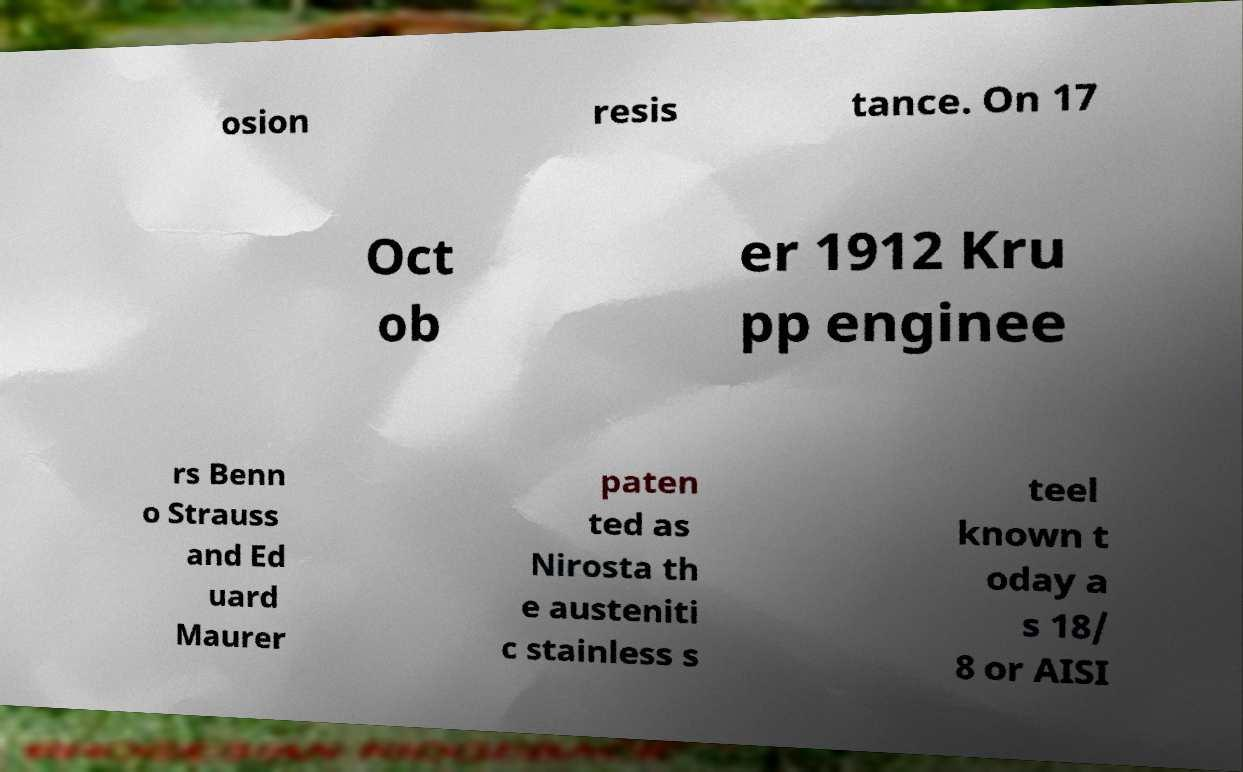Could you assist in decoding the text presented in this image and type it out clearly? osion resis tance. On 17 Oct ob er 1912 Kru pp enginee rs Benn o Strauss and Ed uard Maurer paten ted as Nirosta th e austeniti c stainless s teel known t oday a s 18/ 8 or AISI 